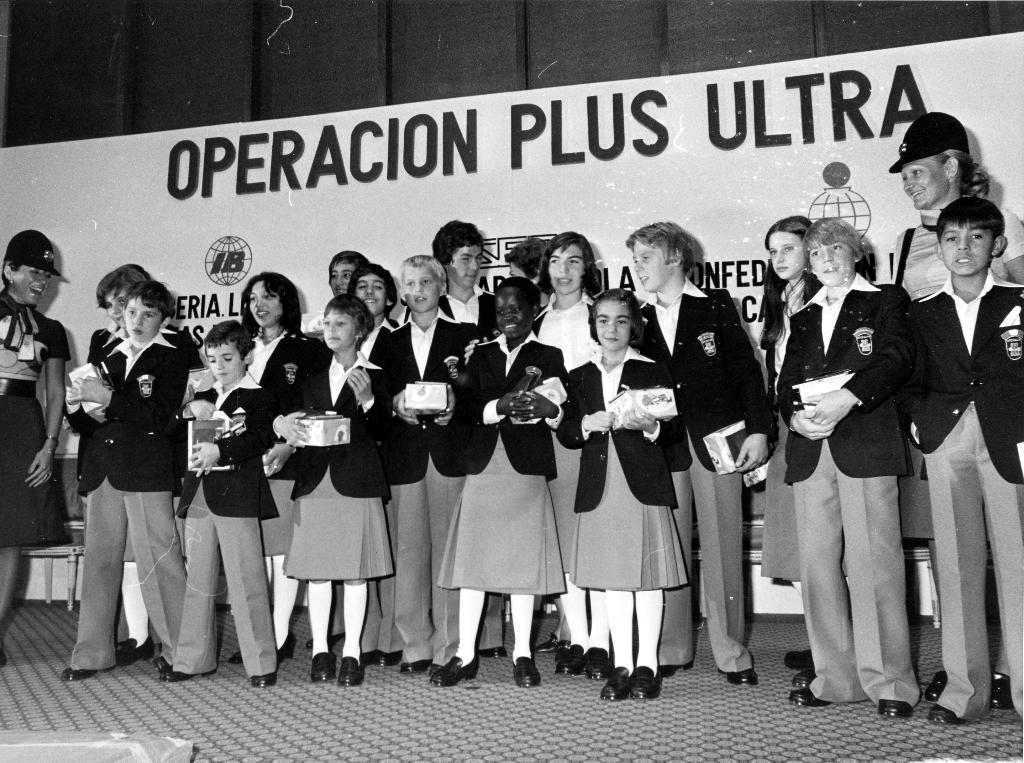What is happening in the image? There are people standing in the image. What are the people holding? The people are holding objects. Can you describe anything in the background of the image? There is a banner or board with text visible in the background of the image. What type of ornament is hanging from the ceiling in the image? There is no ornament hanging from the ceiling in the image. Can you hear any thunder in the image? There is no sound in the image, so it is impossible to determine if there is thunder. 